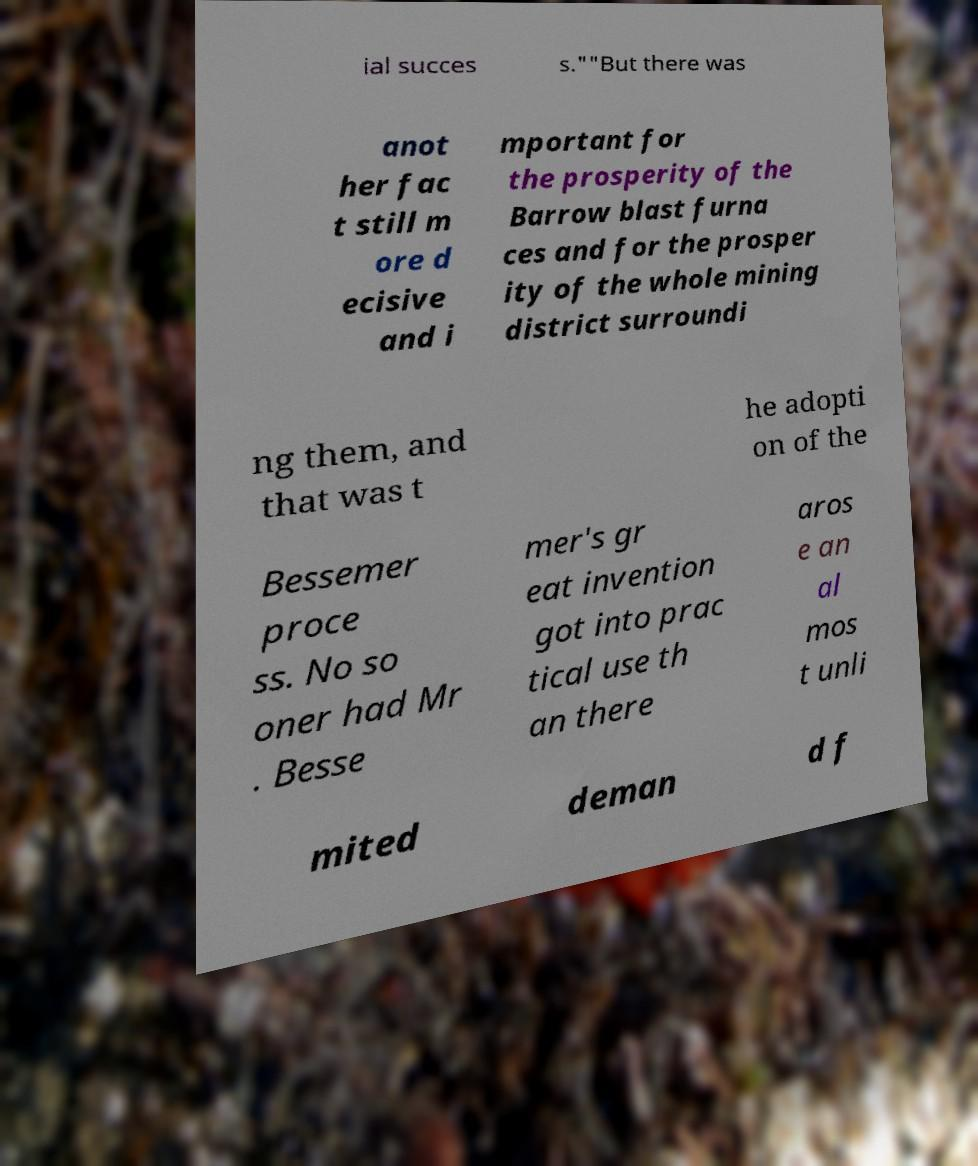Can you read and provide the text displayed in the image?This photo seems to have some interesting text. Can you extract and type it out for me? ial succes s.""But there was anot her fac t still m ore d ecisive and i mportant for the prosperity of the Barrow blast furna ces and for the prosper ity of the whole mining district surroundi ng them, and that was t he adopti on of the Bessemer proce ss. No so oner had Mr . Besse mer's gr eat invention got into prac tical use th an there aros e an al mos t unli mited deman d f 